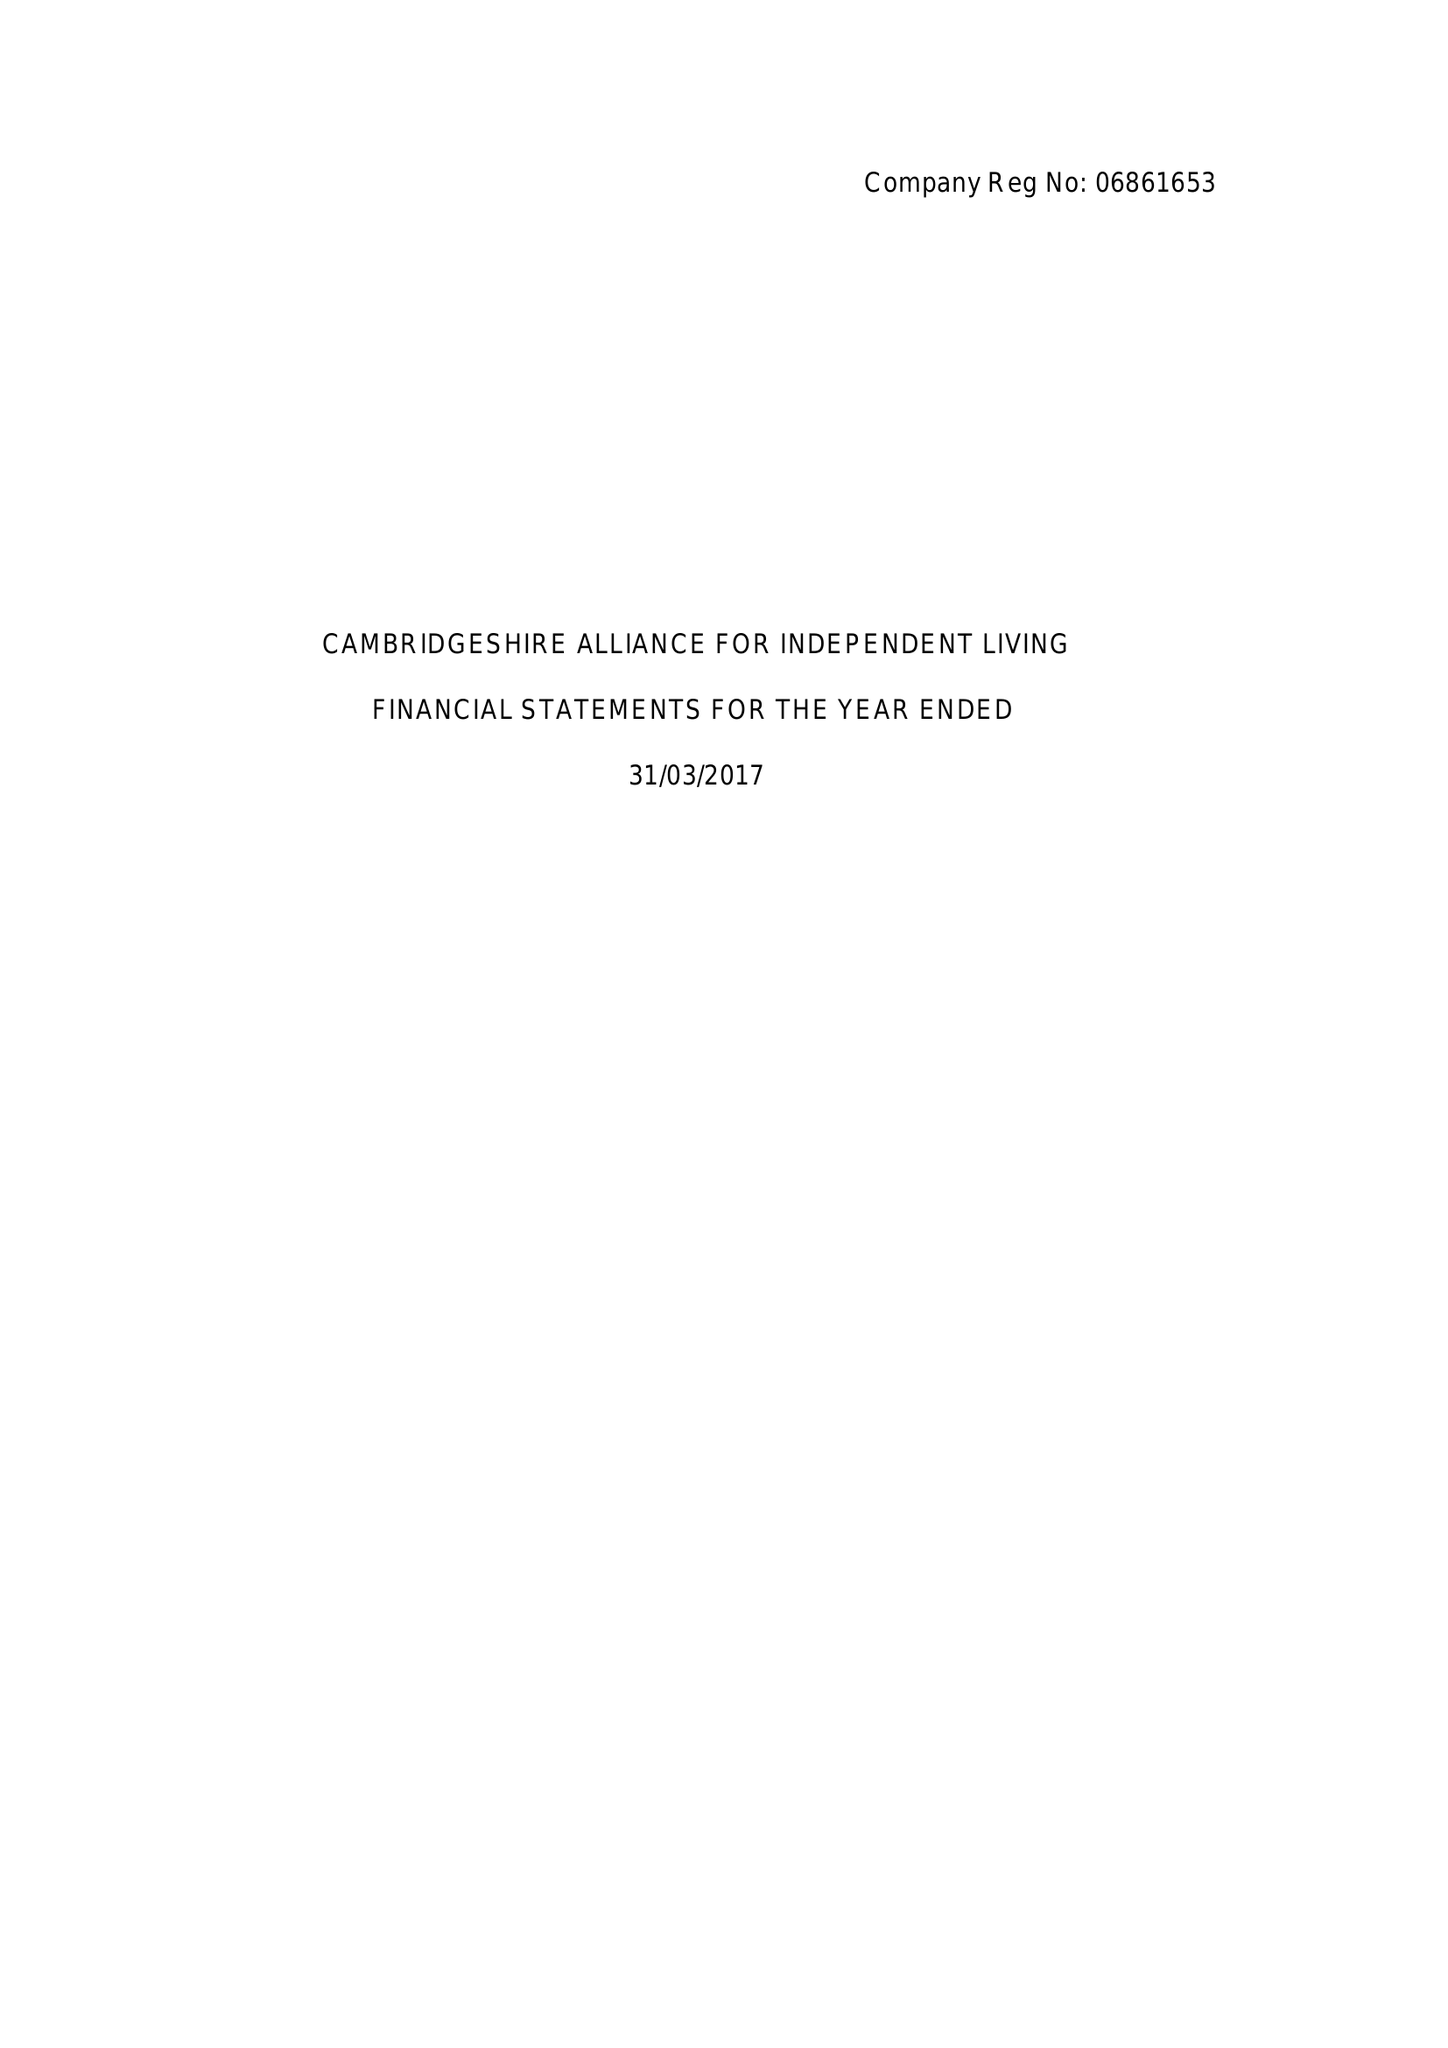What is the value for the charity_number?
Answer the question using a single word or phrase. 1132290 